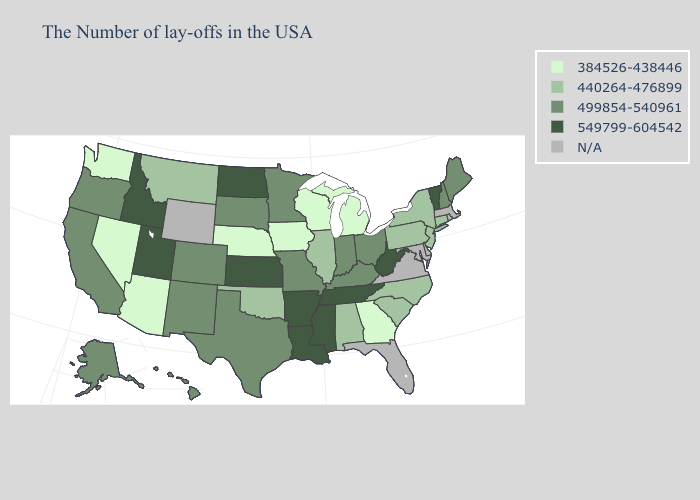What is the value of South Carolina?
Concise answer only. 440264-476899. Among the states that border Nevada , does Idaho have the lowest value?
Write a very short answer. No. What is the lowest value in the Northeast?
Be succinct. 440264-476899. What is the value of Oregon?
Quick response, please. 499854-540961. How many symbols are there in the legend?
Concise answer only. 5. What is the value of North Carolina?
Answer briefly. 440264-476899. What is the highest value in states that border Mississippi?
Be succinct. 549799-604542. Name the states that have a value in the range 440264-476899?
Answer briefly. Rhode Island, Connecticut, New York, New Jersey, Pennsylvania, North Carolina, South Carolina, Alabama, Illinois, Oklahoma, Montana. Does Kansas have the highest value in the USA?
Be succinct. Yes. What is the value of California?
Quick response, please. 499854-540961. What is the value of New Mexico?
Write a very short answer. 499854-540961. What is the lowest value in states that border New Jersey?
Short answer required. 440264-476899. Which states have the lowest value in the MidWest?
Concise answer only. Michigan, Wisconsin, Iowa, Nebraska. What is the value of Kentucky?
Short answer required. 499854-540961. What is the lowest value in the South?
Write a very short answer. 384526-438446. 